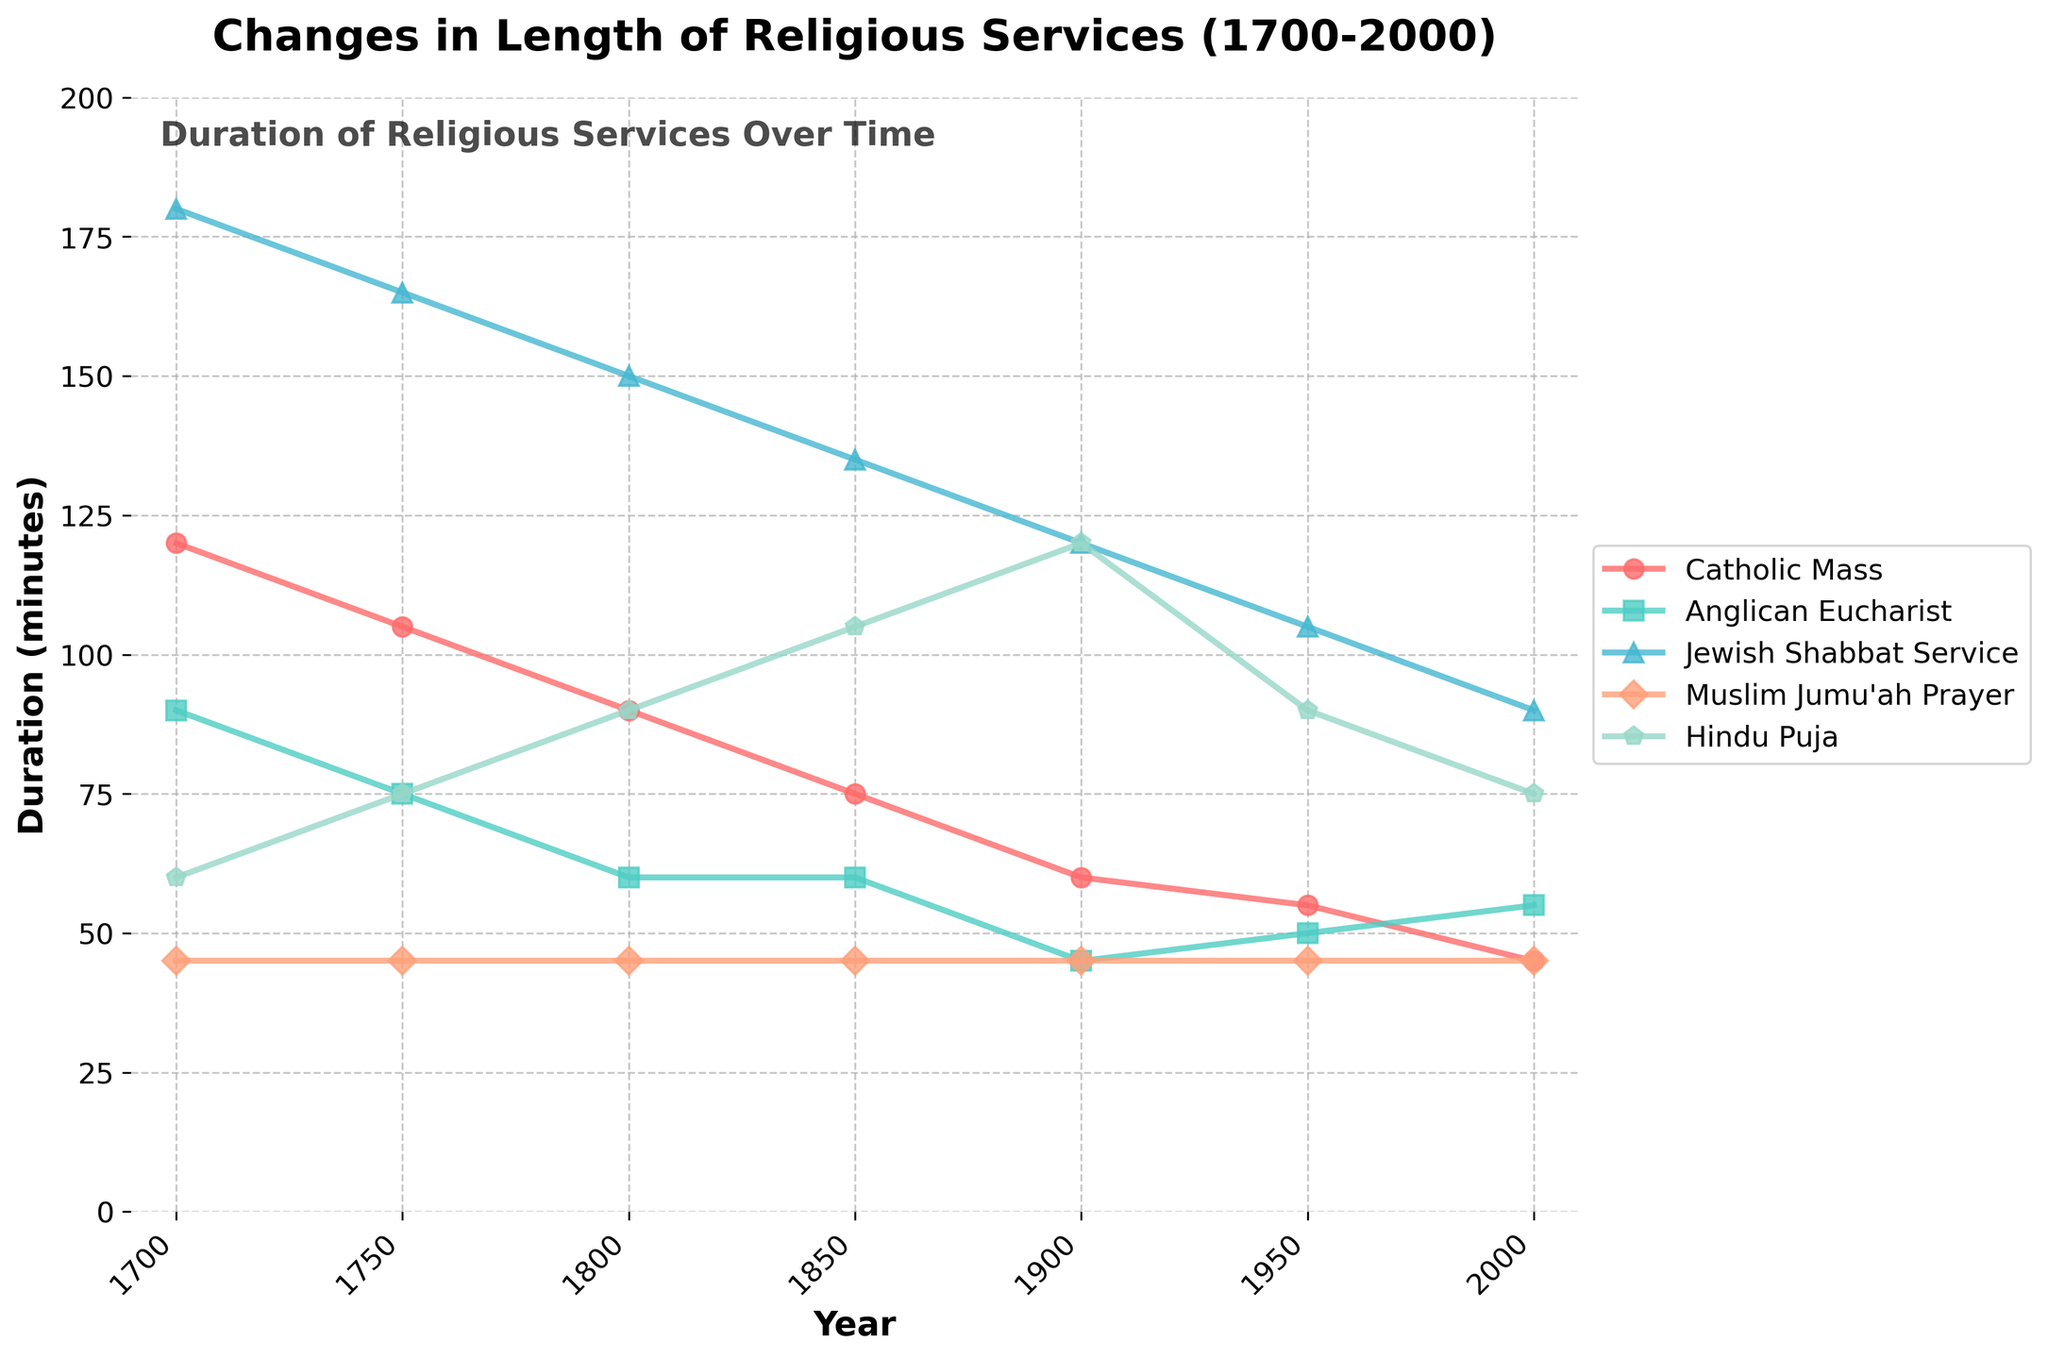What is the overall trend in the duration of Catholic Mass from 1700 to 2000? The plot shows a clear downward trend in the duration of the Catholic Mass over the years from 1700 to 2000. Observing the line corresponding to the Catholic Mass, we see it starting at 120 minutes in 1700 and ending at 45 minutes in 2000, indicating a gradual decrease.
Answer: Decreasing Which religious service had the longest duration in 1750? The visual shows that in 1750, the Jewish Shabbat Service had the longest duration, marked by the highest position on the y-axis among the lines representing the different faiths. The Shabbat Service is at 165 minutes.
Answer: Jewish Shabbat Service How much did the duration of the Hindu Puja increase from 1700 to 1850? To find the increase, we subtract the duration in 1700 from the duration in 1850. The Hindu Puja duration was 60 minutes in 1700 and 105 minutes in 1850. Thus, 105 - 60 = 45 minutes.
Answer: 45 minutes Which two religious services had equal durations at some point between 1700 and 2000? Examining the lines, it is observed that the Anglican Eucharist and Catholic Mass had the same duration of 60 minutes in 1850.
Answer: Anglican Eucharist and Catholic Mass By what percentage did the duration of the Muslim Jumu'ah Prayer remain the same over the years? The Muslim Jumu'ah Prayer line stays constant at 45 minutes from 1700 to 2000. Since it didn’t change, the percentage change is 0%.
Answer: 0% In which year do all religious services but one (Muslim Jumu'ah Prayer) show a reduction in duration compared to their 1700 duration? Observing the plot, in 1900, all services except the Muslim Jumu'ah Prayer show a decrease in duration compared to their 1700 duration.
Answer: 1900 Which two religious services had the most similar duration trends from 1700 to 2000? Visually comparing the plot, the Catholic Mass and Anglican Eucharist have the most similar trends. Both services show a decrease in duration over the years, and their lines follow a somewhat parallel trajectory.
Answer: Catholic Mass and Anglican Eucharist 